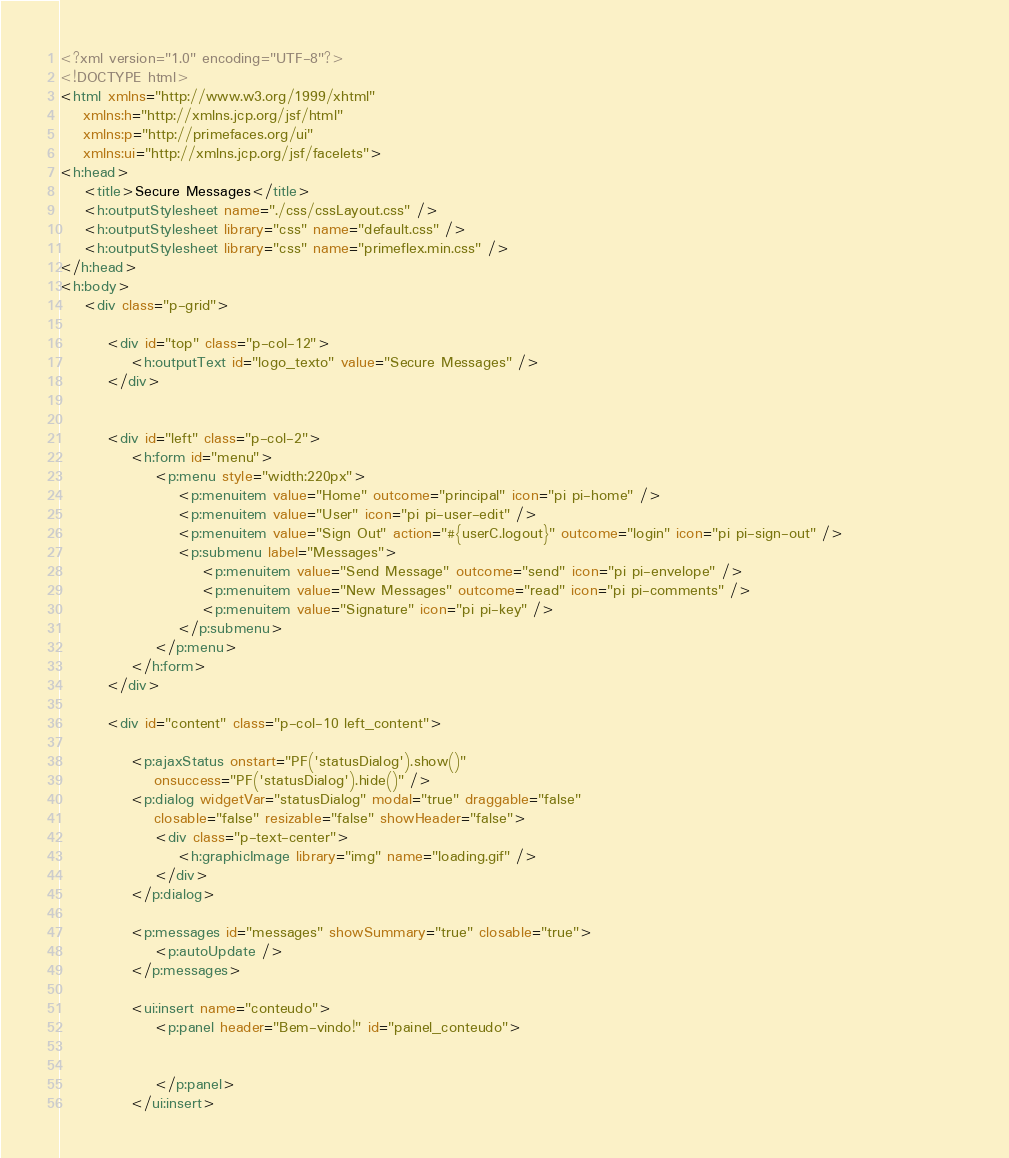Convert code to text. <code><loc_0><loc_0><loc_500><loc_500><_HTML_><?xml version="1.0" encoding="UTF-8"?>
<!DOCTYPE html>
<html xmlns="http://www.w3.org/1999/xhtml"
	xmlns:h="http://xmlns.jcp.org/jsf/html"
	xmlns:p="http://primefaces.org/ui"
	xmlns:ui="http://xmlns.jcp.org/jsf/facelets">
<h:head>
	<title>Secure Messages</title>
	<h:outputStylesheet name="./css/cssLayout.css" />
	<h:outputStylesheet library="css" name="default.css" />
	<h:outputStylesheet library="css" name="primeflex.min.css" />
</h:head>
<h:body>
	<div class="p-grid">

		<div id="top" class="p-col-12">
			<h:outputText id="logo_texto" value="Secure Messages" />
		</div>


		<div id="left" class="p-col-2">
			<h:form id="menu">
				<p:menu style="width:220px">
					<p:menuitem value="Home" outcome="principal" icon="pi pi-home" />
					<p:menuitem value="User" icon="pi pi-user-edit" />		
					<p:menuitem value="Sign Out" action="#{userC.logout}" outcome="login" icon="pi pi-sign-out" />					
					<p:submenu label="Messages">
						<p:menuitem value="Send Message" outcome="send" icon="pi pi-envelope" />
						<p:menuitem value="New Messages" outcome="read" icon="pi pi-comments" />
						<p:menuitem value="Signature" icon="pi pi-key" />
					</p:submenu>					
				</p:menu>
			</h:form>
		</div>

		<div id="content" class="p-col-10 left_content">

			<p:ajaxStatus onstart="PF('statusDialog').show()"
				onsuccess="PF('statusDialog').hide()" />
			<p:dialog widgetVar="statusDialog" modal="true" draggable="false"
				closable="false" resizable="false" showHeader="false">
				<div class="p-text-center">
					<h:graphicImage library="img" name="loading.gif" />
				</div>
			</p:dialog>

			<p:messages id="messages" showSummary="true" closable="true">
				<p:autoUpdate />
			</p:messages>

			<ui:insert name="conteudo">
				<p:panel header="Bem-vindo!" id="painel_conteudo">
					

				</p:panel>
			</ui:insert>
</code> 